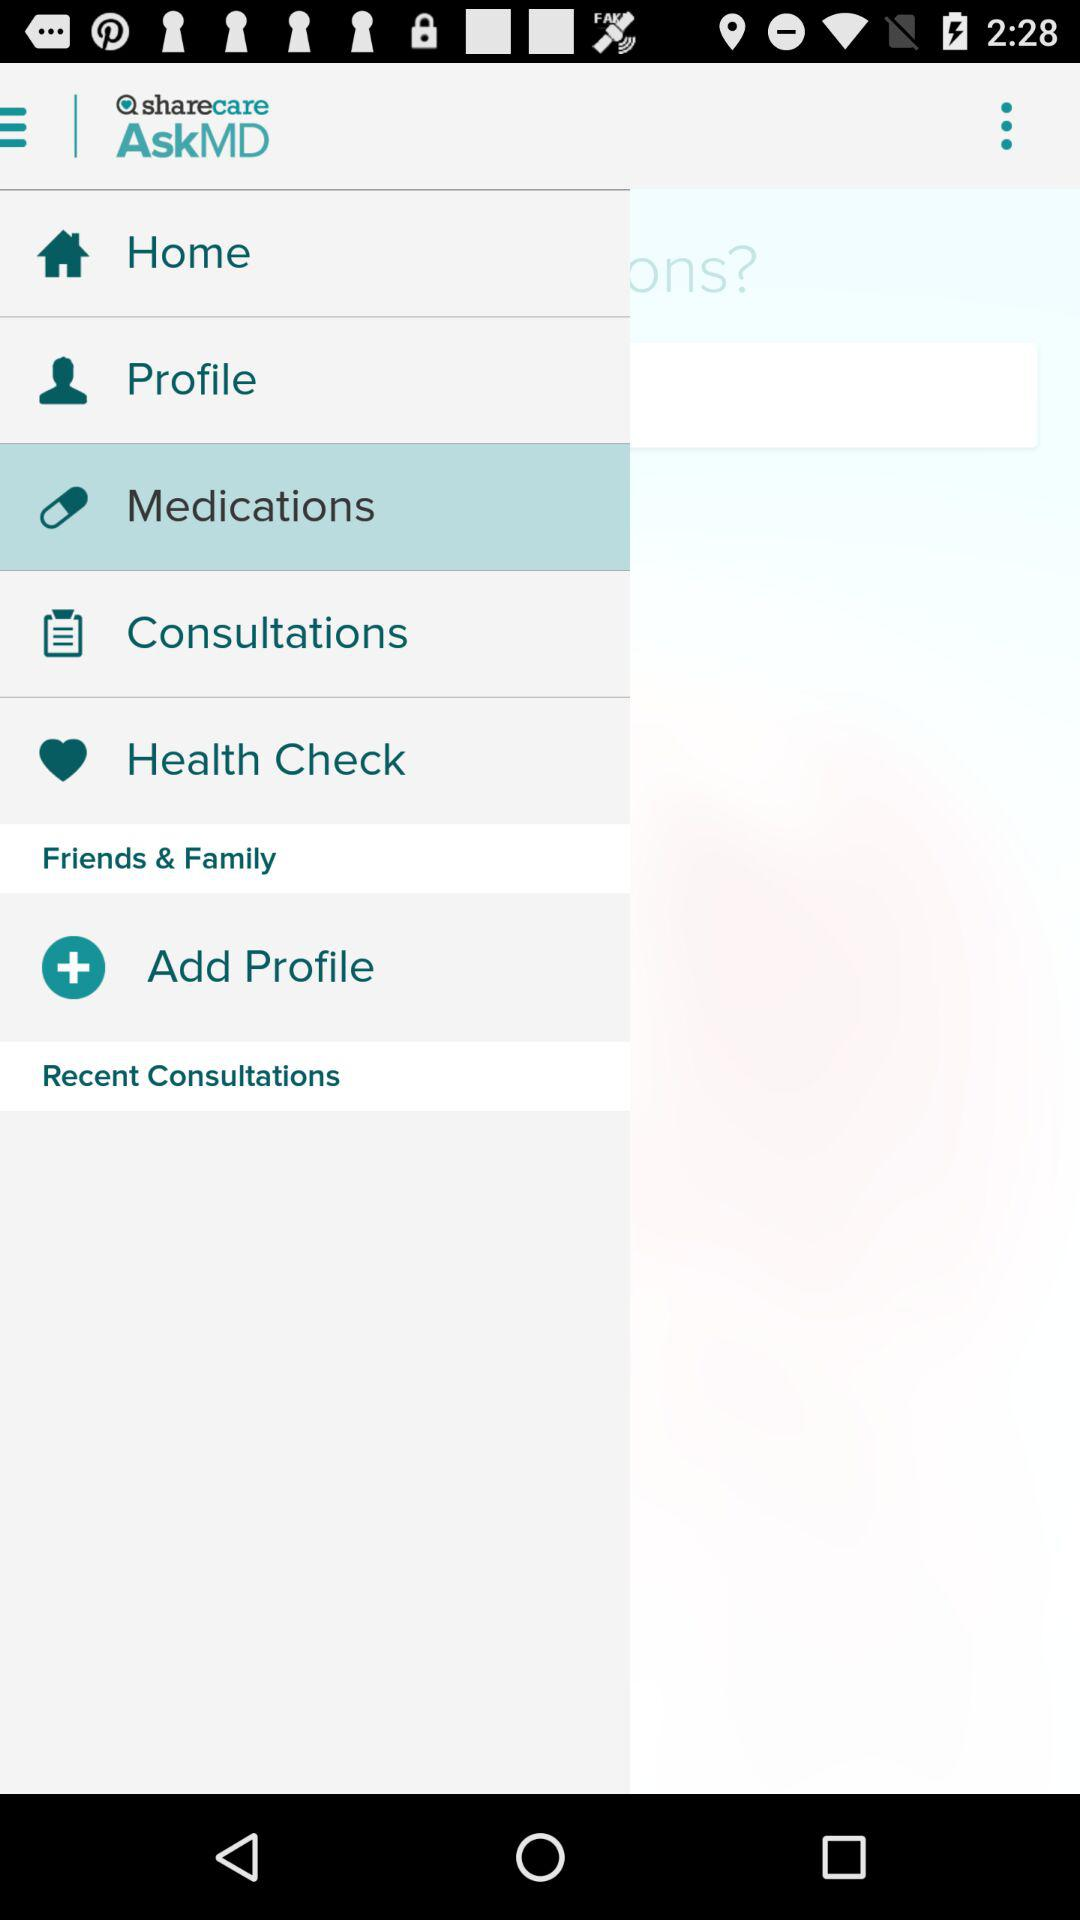Which option is selected? The selected option is "Medications". 